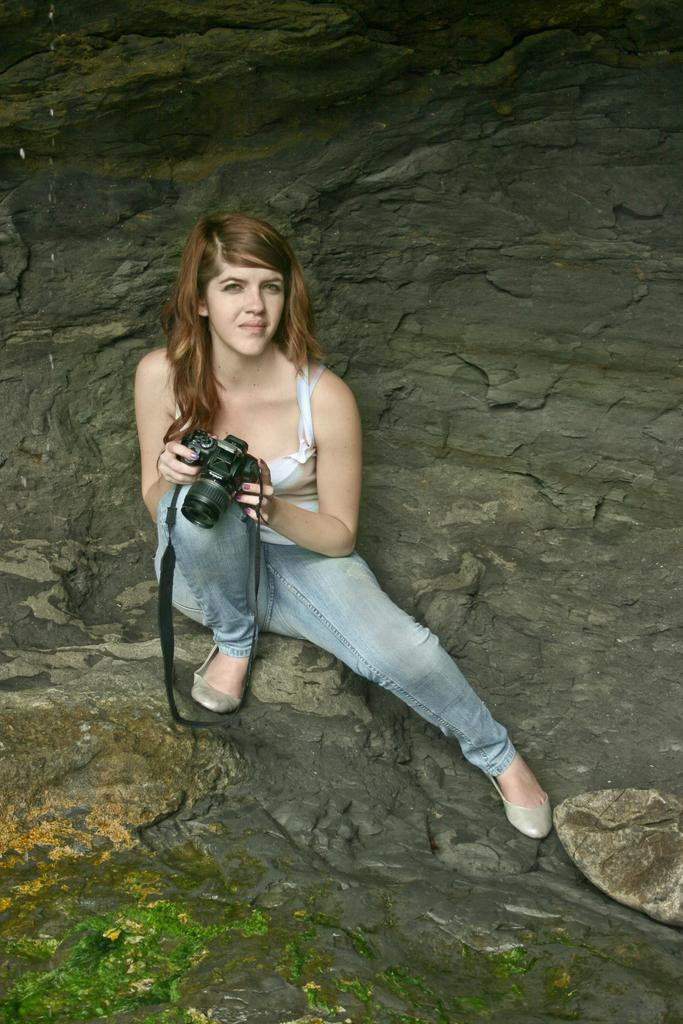Who is the main subject in the image? There is a woman in the image. What is the woman holding in the image? The woman is holding a camera. What can be seen in the background of the image? There is a rock in the background of the image. What type of invention can be seen in the woman's hand in the image? There is no invention present in the woman's hand in the image; she is holding a camera. What kind of breakfast is the woman eating in the image? There is no breakfast present in the image; the woman is holding a camera. 